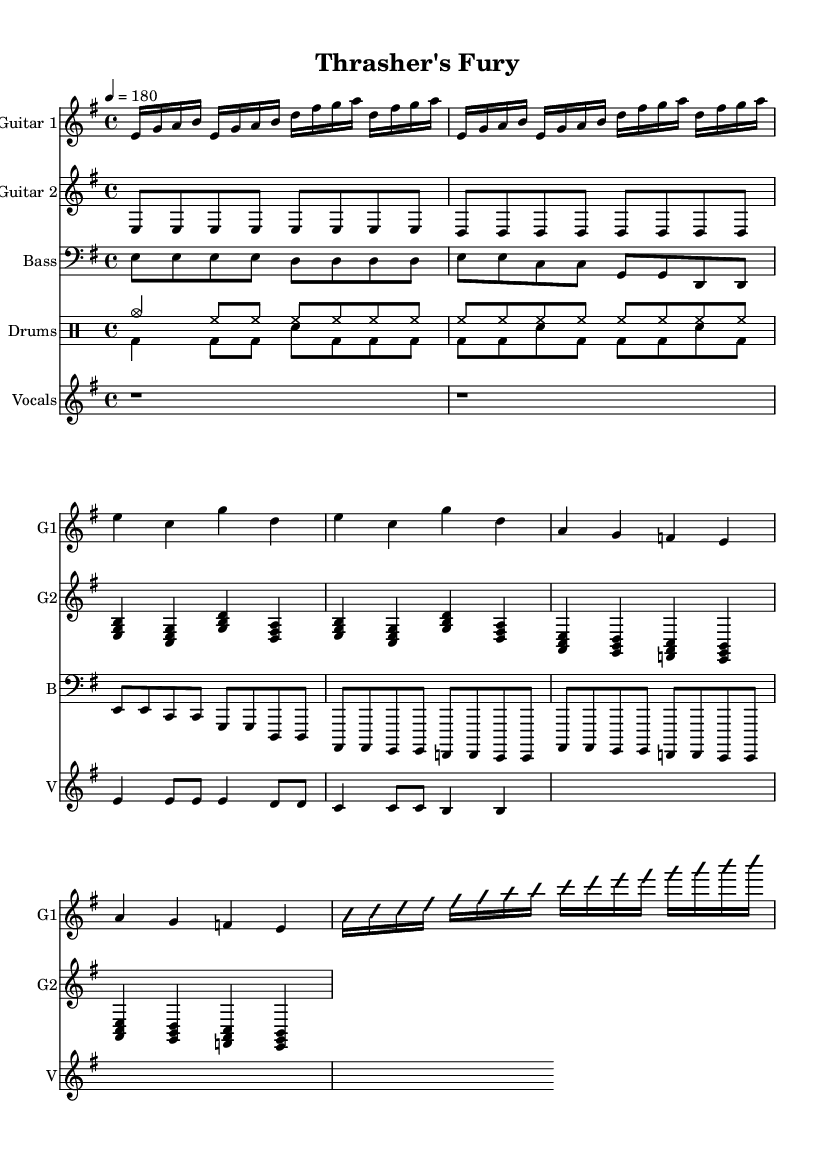What is the key signature of this music? The key signature of the music is found at the beginning of the sheet music, showing one sharp (F#), which indicates E minor, the relative minor of G major.
Answer: E minor What is the time signature of this music? The time signature can be located at the start of the sheet music, where it indicates 4/4, meaning there are four beats in each measure, and the quarter note gets one beat.
Answer: 4/4 What is the tempo marking for this music? The tempo marking is indicated in a format that shows the speed of the piece. "4 = 180" means there are 180 beats per minute, and it is a fast-paced tempo appropriate for thrash metal.
Answer: 180 How many measures are there in the intro? By counting the measures within the section labeled "Intro," we see there are a total of 2 measures repeated for the intro, as indicated by the repeat symbol.
Answer: 2 What is the main theme of the vocals in the verse? The lyrics given for the vocals section indicate a theme of "thrashing through the night" and the idea of metal being in one's veins, demonstrating typical themes found in thrash metal.
Answer: Thrashing through the night, metal in my veins Which instruments are present in this sheet music? By examining the score, we recognize several distinct parts for different instruments: Guitar 1, Guitar 2, Bass, Drums, and Vocals, providing a fuller band setup typical for a thrash metal song.
Answer: Guitar 1, Guitar 2, Bass, Drums, Vocals What type of guitar technique is likely used during the guitar solo? The notation for the guitar solo section is labeled with "improvisationOn," suggesting that a lead guitar technique characterized by spontaneous solos is utilized here, common in metal music.
Answer: Improvisation 